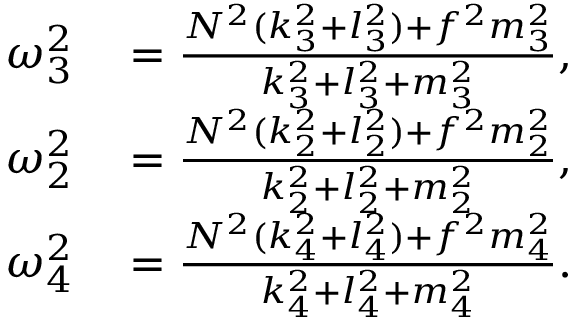Convert formula to latex. <formula><loc_0><loc_0><loc_500><loc_500>\begin{array} { r l } { \omega _ { 3 } ^ { 2 } } & = \frac { N ^ { 2 } ( k _ { 3 } ^ { 2 } + l _ { 3 } ^ { 2 } ) + f ^ { 2 } m _ { 3 } ^ { 2 } } { k _ { 3 } ^ { 2 } + l _ { 3 } ^ { 2 } + m _ { 3 } ^ { 2 } } , } \\ { \omega _ { 2 } ^ { 2 } } & = \frac { N ^ { 2 } ( k _ { 2 } ^ { 2 } + l _ { 2 } ^ { 2 } ) + f ^ { 2 } m _ { 2 } ^ { 2 } } { k _ { 2 } ^ { 2 } + l _ { 2 } ^ { 2 } + m _ { 2 } ^ { 2 } } , } \\ { \omega _ { 4 } ^ { 2 } } & = \frac { N ^ { 2 } ( k _ { 4 } ^ { 2 } + l _ { 4 } ^ { 2 } ) + f ^ { 2 } m _ { 4 } ^ { 2 } } { k _ { 4 } ^ { 2 } + l _ { 4 } ^ { 2 } + m _ { 4 } ^ { 2 } } . } \end{array}</formula> 